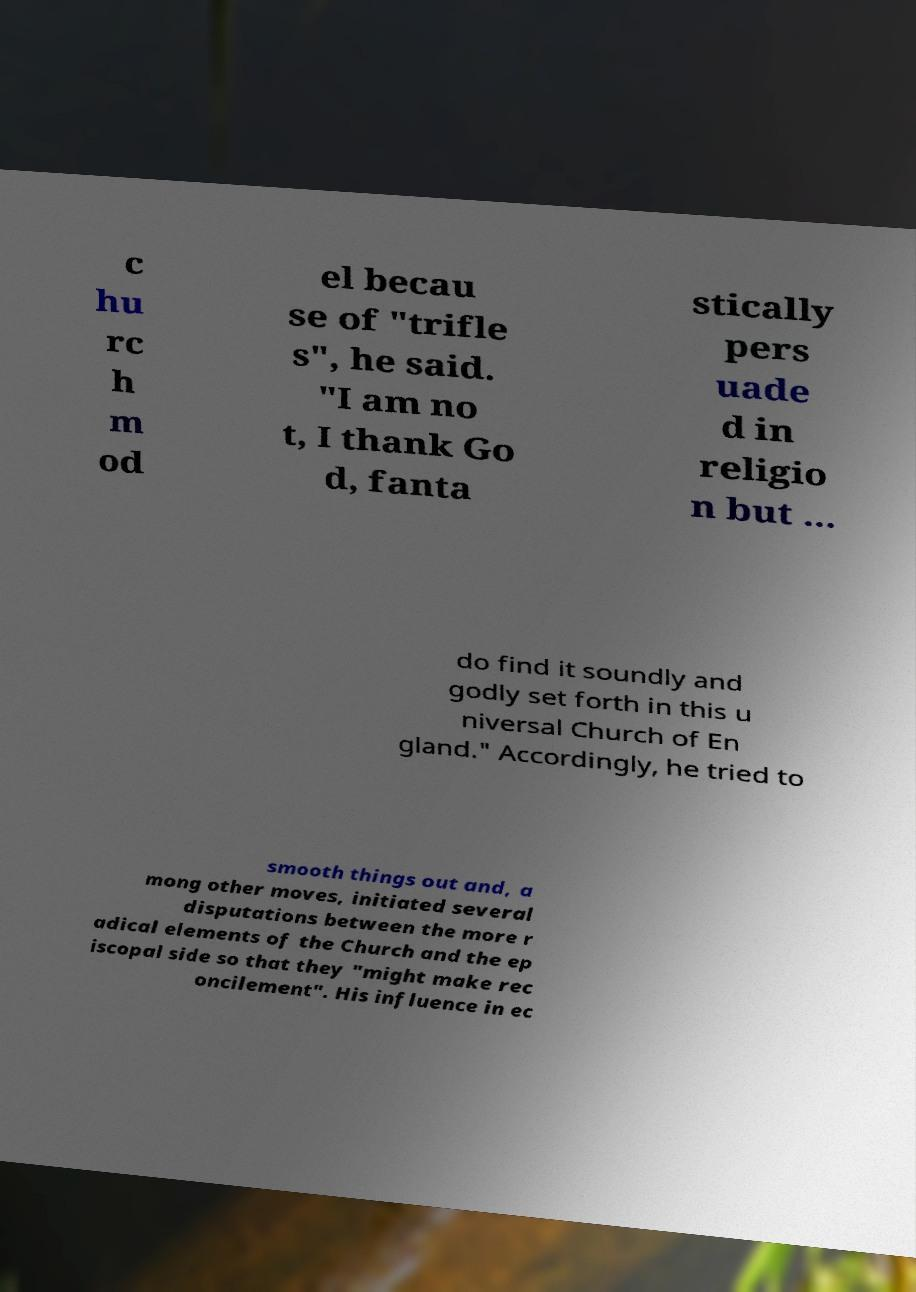For documentation purposes, I need the text within this image transcribed. Could you provide that? c hu rc h m od el becau se of "trifle s", he said. "I am no t, I thank Go d, fanta stically pers uade d in religio n but ... do find it soundly and godly set forth in this u niversal Church of En gland." Accordingly, he tried to smooth things out and, a mong other moves, initiated several disputations between the more r adical elements of the Church and the ep iscopal side so that they "might make rec oncilement". His influence in ec 